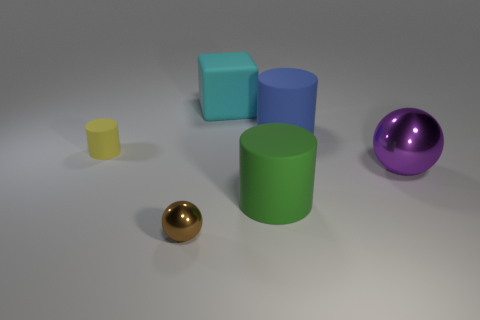Add 1 brown balls. How many objects exist? 7 Subtract all gray cylinders. Subtract all blue blocks. How many cylinders are left? 3 Subtract all balls. How many objects are left? 4 Add 6 yellow metallic cubes. How many yellow metallic cubes exist? 6 Subtract 1 brown balls. How many objects are left? 5 Subtract all tiny yellow metallic blocks. Subtract all big cubes. How many objects are left? 5 Add 5 shiny things. How many shiny things are left? 7 